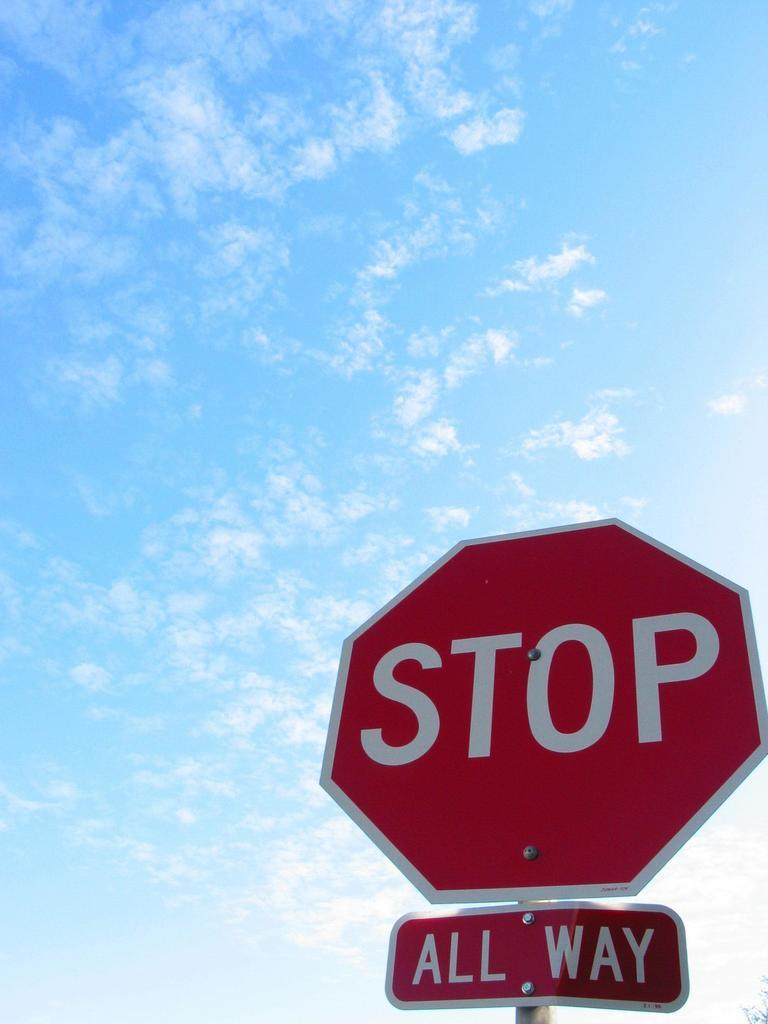<image>
Relay a brief, clear account of the picture shown. An all way stop sign with a blue sky and tiny puffy white clouds. 